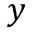<formula> <loc_0><loc_0><loc_500><loc_500>y</formula> 